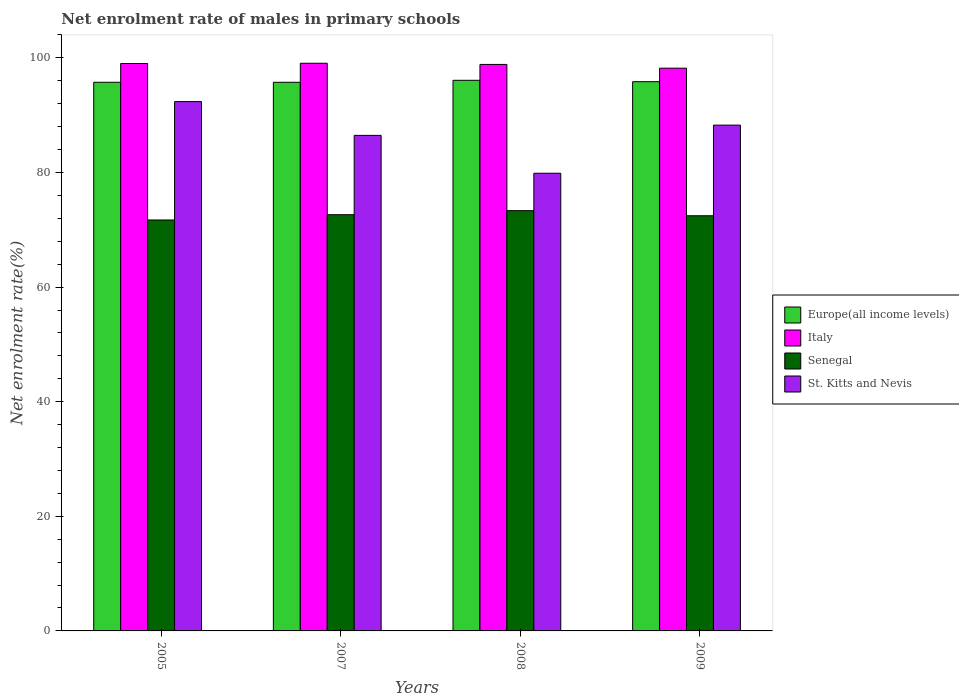How many groups of bars are there?
Your answer should be very brief. 4. Are the number of bars on each tick of the X-axis equal?
Your response must be concise. Yes. What is the net enrolment rate of males in primary schools in Senegal in 2005?
Give a very brief answer. 71.71. Across all years, what is the maximum net enrolment rate of males in primary schools in Senegal?
Your response must be concise. 73.33. Across all years, what is the minimum net enrolment rate of males in primary schools in Europe(all income levels)?
Provide a succinct answer. 95.74. What is the total net enrolment rate of males in primary schools in St. Kitts and Nevis in the graph?
Offer a very short reply. 346.96. What is the difference between the net enrolment rate of males in primary schools in Europe(all income levels) in 2008 and that in 2009?
Your response must be concise. 0.24. What is the difference between the net enrolment rate of males in primary schools in Senegal in 2008 and the net enrolment rate of males in primary schools in Europe(all income levels) in 2007?
Your answer should be very brief. -22.4. What is the average net enrolment rate of males in primary schools in St. Kitts and Nevis per year?
Offer a very short reply. 86.74. In the year 2009, what is the difference between the net enrolment rate of males in primary schools in Italy and net enrolment rate of males in primary schools in Senegal?
Offer a terse response. 25.75. What is the ratio of the net enrolment rate of males in primary schools in St. Kitts and Nevis in 2007 to that in 2009?
Provide a succinct answer. 0.98. Is the net enrolment rate of males in primary schools in Italy in 2008 less than that in 2009?
Your answer should be compact. No. What is the difference between the highest and the second highest net enrolment rate of males in primary schools in Europe(all income levels)?
Give a very brief answer. 0.24. What is the difference between the highest and the lowest net enrolment rate of males in primary schools in Italy?
Offer a terse response. 0.86. In how many years, is the net enrolment rate of males in primary schools in Senegal greater than the average net enrolment rate of males in primary schools in Senegal taken over all years?
Offer a terse response. 2. Is it the case that in every year, the sum of the net enrolment rate of males in primary schools in Europe(all income levels) and net enrolment rate of males in primary schools in Italy is greater than the sum of net enrolment rate of males in primary schools in Senegal and net enrolment rate of males in primary schools in St. Kitts and Nevis?
Your answer should be very brief. Yes. What does the 3rd bar from the left in 2008 represents?
Keep it short and to the point. Senegal. What does the 1st bar from the right in 2005 represents?
Your answer should be compact. St. Kitts and Nevis. How many bars are there?
Your answer should be very brief. 16. Are all the bars in the graph horizontal?
Offer a terse response. No. What is the difference between two consecutive major ticks on the Y-axis?
Provide a succinct answer. 20. Are the values on the major ticks of Y-axis written in scientific E-notation?
Ensure brevity in your answer.  No. Where does the legend appear in the graph?
Provide a succinct answer. Center right. How are the legend labels stacked?
Offer a very short reply. Vertical. What is the title of the graph?
Provide a short and direct response. Net enrolment rate of males in primary schools. Does "El Salvador" appear as one of the legend labels in the graph?
Make the answer very short. No. What is the label or title of the X-axis?
Give a very brief answer. Years. What is the label or title of the Y-axis?
Ensure brevity in your answer.  Net enrolment rate(%). What is the Net enrolment rate(%) of Europe(all income levels) in 2005?
Keep it short and to the point. 95.74. What is the Net enrolment rate(%) of Italy in 2005?
Your answer should be compact. 99.01. What is the Net enrolment rate(%) of Senegal in 2005?
Make the answer very short. 71.71. What is the Net enrolment rate(%) in St. Kitts and Nevis in 2005?
Keep it short and to the point. 92.36. What is the Net enrolment rate(%) of Europe(all income levels) in 2007?
Make the answer very short. 95.74. What is the Net enrolment rate(%) in Italy in 2007?
Keep it short and to the point. 99.06. What is the Net enrolment rate(%) in Senegal in 2007?
Your response must be concise. 72.63. What is the Net enrolment rate(%) of St. Kitts and Nevis in 2007?
Your answer should be compact. 86.47. What is the Net enrolment rate(%) in Europe(all income levels) in 2008?
Make the answer very short. 96.08. What is the Net enrolment rate(%) of Italy in 2008?
Offer a terse response. 98.85. What is the Net enrolment rate(%) in Senegal in 2008?
Offer a terse response. 73.33. What is the Net enrolment rate(%) in St. Kitts and Nevis in 2008?
Give a very brief answer. 79.86. What is the Net enrolment rate(%) of Europe(all income levels) in 2009?
Give a very brief answer. 95.84. What is the Net enrolment rate(%) of Italy in 2009?
Offer a terse response. 98.2. What is the Net enrolment rate(%) of Senegal in 2009?
Your answer should be very brief. 72.45. What is the Net enrolment rate(%) in St. Kitts and Nevis in 2009?
Your response must be concise. 88.26. Across all years, what is the maximum Net enrolment rate(%) in Europe(all income levels)?
Your answer should be very brief. 96.08. Across all years, what is the maximum Net enrolment rate(%) of Italy?
Your answer should be very brief. 99.06. Across all years, what is the maximum Net enrolment rate(%) in Senegal?
Your response must be concise. 73.33. Across all years, what is the maximum Net enrolment rate(%) of St. Kitts and Nevis?
Provide a succinct answer. 92.36. Across all years, what is the minimum Net enrolment rate(%) in Europe(all income levels)?
Make the answer very short. 95.74. Across all years, what is the minimum Net enrolment rate(%) of Italy?
Provide a short and direct response. 98.2. Across all years, what is the minimum Net enrolment rate(%) of Senegal?
Your response must be concise. 71.71. Across all years, what is the minimum Net enrolment rate(%) in St. Kitts and Nevis?
Your response must be concise. 79.86. What is the total Net enrolment rate(%) in Europe(all income levels) in the graph?
Ensure brevity in your answer.  383.39. What is the total Net enrolment rate(%) in Italy in the graph?
Provide a succinct answer. 395.12. What is the total Net enrolment rate(%) in Senegal in the graph?
Your answer should be very brief. 290.12. What is the total Net enrolment rate(%) of St. Kitts and Nevis in the graph?
Keep it short and to the point. 346.96. What is the difference between the Net enrolment rate(%) of Europe(all income levels) in 2005 and that in 2007?
Provide a short and direct response. 0. What is the difference between the Net enrolment rate(%) in Italy in 2005 and that in 2007?
Your response must be concise. -0.04. What is the difference between the Net enrolment rate(%) in Senegal in 2005 and that in 2007?
Your response must be concise. -0.92. What is the difference between the Net enrolment rate(%) of St. Kitts and Nevis in 2005 and that in 2007?
Offer a terse response. 5.89. What is the difference between the Net enrolment rate(%) of Europe(all income levels) in 2005 and that in 2008?
Offer a very short reply. -0.34. What is the difference between the Net enrolment rate(%) of Italy in 2005 and that in 2008?
Give a very brief answer. 0.16. What is the difference between the Net enrolment rate(%) of Senegal in 2005 and that in 2008?
Provide a short and direct response. -1.63. What is the difference between the Net enrolment rate(%) of St. Kitts and Nevis in 2005 and that in 2008?
Provide a short and direct response. 12.5. What is the difference between the Net enrolment rate(%) in Europe(all income levels) in 2005 and that in 2009?
Provide a succinct answer. -0.1. What is the difference between the Net enrolment rate(%) of Italy in 2005 and that in 2009?
Provide a succinct answer. 0.81. What is the difference between the Net enrolment rate(%) in Senegal in 2005 and that in 2009?
Provide a succinct answer. -0.74. What is the difference between the Net enrolment rate(%) in St. Kitts and Nevis in 2005 and that in 2009?
Provide a short and direct response. 4.1. What is the difference between the Net enrolment rate(%) of Europe(all income levels) in 2007 and that in 2008?
Ensure brevity in your answer.  -0.34. What is the difference between the Net enrolment rate(%) in Italy in 2007 and that in 2008?
Your answer should be very brief. 0.2. What is the difference between the Net enrolment rate(%) in Senegal in 2007 and that in 2008?
Offer a very short reply. -0.71. What is the difference between the Net enrolment rate(%) in St. Kitts and Nevis in 2007 and that in 2008?
Make the answer very short. 6.61. What is the difference between the Net enrolment rate(%) in Europe(all income levels) in 2007 and that in 2009?
Your response must be concise. -0.1. What is the difference between the Net enrolment rate(%) of Italy in 2007 and that in 2009?
Give a very brief answer. 0.86. What is the difference between the Net enrolment rate(%) in Senegal in 2007 and that in 2009?
Offer a very short reply. 0.18. What is the difference between the Net enrolment rate(%) of St. Kitts and Nevis in 2007 and that in 2009?
Give a very brief answer. -1.79. What is the difference between the Net enrolment rate(%) of Europe(all income levels) in 2008 and that in 2009?
Provide a short and direct response. 0.24. What is the difference between the Net enrolment rate(%) in Italy in 2008 and that in 2009?
Offer a very short reply. 0.65. What is the difference between the Net enrolment rate(%) of Senegal in 2008 and that in 2009?
Make the answer very short. 0.89. What is the difference between the Net enrolment rate(%) in St. Kitts and Nevis in 2008 and that in 2009?
Offer a terse response. -8.4. What is the difference between the Net enrolment rate(%) of Europe(all income levels) in 2005 and the Net enrolment rate(%) of Italy in 2007?
Provide a succinct answer. -3.32. What is the difference between the Net enrolment rate(%) of Europe(all income levels) in 2005 and the Net enrolment rate(%) of Senegal in 2007?
Ensure brevity in your answer.  23.11. What is the difference between the Net enrolment rate(%) in Europe(all income levels) in 2005 and the Net enrolment rate(%) in St. Kitts and Nevis in 2007?
Offer a terse response. 9.27. What is the difference between the Net enrolment rate(%) in Italy in 2005 and the Net enrolment rate(%) in Senegal in 2007?
Your response must be concise. 26.38. What is the difference between the Net enrolment rate(%) in Italy in 2005 and the Net enrolment rate(%) in St. Kitts and Nevis in 2007?
Give a very brief answer. 12.54. What is the difference between the Net enrolment rate(%) of Senegal in 2005 and the Net enrolment rate(%) of St. Kitts and Nevis in 2007?
Provide a succinct answer. -14.76. What is the difference between the Net enrolment rate(%) of Europe(all income levels) in 2005 and the Net enrolment rate(%) of Italy in 2008?
Offer a very short reply. -3.11. What is the difference between the Net enrolment rate(%) of Europe(all income levels) in 2005 and the Net enrolment rate(%) of Senegal in 2008?
Your answer should be compact. 22.4. What is the difference between the Net enrolment rate(%) in Europe(all income levels) in 2005 and the Net enrolment rate(%) in St. Kitts and Nevis in 2008?
Offer a very short reply. 15.87. What is the difference between the Net enrolment rate(%) in Italy in 2005 and the Net enrolment rate(%) in Senegal in 2008?
Your response must be concise. 25.68. What is the difference between the Net enrolment rate(%) in Italy in 2005 and the Net enrolment rate(%) in St. Kitts and Nevis in 2008?
Keep it short and to the point. 19.15. What is the difference between the Net enrolment rate(%) in Senegal in 2005 and the Net enrolment rate(%) in St. Kitts and Nevis in 2008?
Provide a short and direct response. -8.15. What is the difference between the Net enrolment rate(%) in Europe(all income levels) in 2005 and the Net enrolment rate(%) in Italy in 2009?
Keep it short and to the point. -2.46. What is the difference between the Net enrolment rate(%) of Europe(all income levels) in 2005 and the Net enrolment rate(%) of Senegal in 2009?
Give a very brief answer. 23.29. What is the difference between the Net enrolment rate(%) in Europe(all income levels) in 2005 and the Net enrolment rate(%) in St. Kitts and Nevis in 2009?
Offer a terse response. 7.48. What is the difference between the Net enrolment rate(%) of Italy in 2005 and the Net enrolment rate(%) of Senegal in 2009?
Provide a succinct answer. 26.57. What is the difference between the Net enrolment rate(%) of Italy in 2005 and the Net enrolment rate(%) of St. Kitts and Nevis in 2009?
Offer a terse response. 10.75. What is the difference between the Net enrolment rate(%) of Senegal in 2005 and the Net enrolment rate(%) of St. Kitts and Nevis in 2009?
Offer a terse response. -16.55. What is the difference between the Net enrolment rate(%) of Europe(all income levels) in 2007 and the Net enrolment rate(%) of Italy in 2008?
Keep it short and to the point. -3.12. What is the difference between the Net enrolment rate(%) of Europe(all income levels) in 2007 and the Net enrolment rate(%) of Senegal in 2008?
Your answer should be very brief. 22.4. What is the difference between the Net enrolment rate(%) of Europe(all income levels) in 2007 and the Net enrolment rate(%) of St. Kitts and Nevis in 2008?
Provide a short and direct response. 15.87. What is the difference between the Net enrolment rate(%) of Italy in 2007 and the Net enrolment rate(%) of Senegal in 2008?
Give a very brief answer. 25.72. What is the difference between the Net enrolment rate(%) in Italy in 2007 and the Net enrolment rate(%) in St. Kitts and Nevis in 2008?
Provide a short and direct response. 19.19. What is the difference between the Net enrolment rate(%) of Senegal in 2007 and the Net enrolment rate(%) of St. Kitts and Nevis in 2008?
Offer a very short reply. -7.24. What is the difference between the Net enrolment rate(%) of Europe(all income levels) in 2007 and the Net enrolment rate(%) of Italy in 2009?
Provide a succinct answer. -2.46. What is the difference between the Net enrolment rate(%) in Europe(all income levels) in 2007 and the Net enrolment rate(%) in Senegal in 2009?
Give a very brief answer. 23.29. What is the difference between the Net enrolment rate(%) in Europe(all income levels) in 2007 and the Net enrolment rate(%) in St. Kitts and Nevis in 2009?
Your answer should be very brief. 7.47. What is the difference between the Net enrolment rate(%) in Italy in 2007 and the Net enrolment rate(%) in Senegal in 2009?
Your response must be concise. 26.61. What is the difference between the Net enrolment rate(%) of Italy in 2007 and the Net enrolment rate(%) of St. Kitts and Nevis in 2009?
Make the answer very short. 10.8. What is the difference between the Net enrolment rate(%) of Senegal in 2007 and the Net enrolment rate(%) of St. Kitts and Nevis in 2009?
Offer a very short reply. -15.63. What is the difference between the Net enrolment rate(%) of Europe(all income levels) in 2008 and the Net enrolment rate(%) of Italy in 2009?
Your response must be concise. -2.12. What is the difference between the Net enrolment rate(%) in Europe(all income levels) in 2008 and the Net enrolment rate(%) in Senegal in 2009?
Give a very brief answer. 23.64. What is the difference between the Net enrolment rate(%) of Europe(all income levels) in 2008 and the Net enrolment rate(%) of St. Kitts and Nevis in 2009?
Give a very brief answer. 7.82. What is the difference between the Net enrolment rate(%) in Italy in 2008 and the Net enrolment rate(%) in Senegal in 2009?
Ensure brevity in your answer.  26.41. What is the difference between the Net enrolment rate(%) in Italy in 2008 and the Net enrolment rate(%) in St. Kitts and Nevis in 2009?
Provide a succinct answer. 10.59. What is the difference between the Net enrolment rate(%) of Senegal in 2008 and the Net enrolment rate(%) of St. Kitts and Nevis in 2009?
Give a very brief answer. -14.93. What is the average Net enrolment rate(%) of Europe(all income levels) per year?
Offer a terse response. 95.85. What is the average Net enrolment rate(%) in Italy per year?
Your answer should be very brief. 98.78. What is the average Net enrolment rate(%) of Senegal per year?
Your response must be concise. 72.53. What is the average Net enrolment rate(%) of St. Kitts and Nevis per year?
Offer a very short reply. 86.74. In the year 2005, what is the difference between the Net enrolment rate(%) in Europe(all income levels) and Net enrolment rate(%) in Italy?
Ensure brevity in your answer.  -3.27. In the year 2005, what is the difference between the Net enrolment rate(%) of Europe(all income levels) and Net enrolment rate(%) of Senegal?
Your answer should be compact. 24.03. In the year 2005, what is the difference between the Net enrolment rate(%) of Europe(all income levels) and Net enrolment rate(%) of St. Kitts and Nevis?
Offer a terse response. 3.37. In the year 2005, what is the difference between the Net enrolment rate(%) in Italy and Net enrolment rate(%) in Senegal?
Provide a short and direct response. 27.3. In the year 2005, what is the difference between the Net enrolment rate(%) of Italy and Net enrolment rate(%) of St. Kitts and Nevis?
Offer a very short reply. 6.65. In the year 2005, what is the difference between the Net enrolment rate(%) in Senegal and Net enrolment rate(%) in St. Kitts and Nevis?
Make the answer very short. -20.66. In the year 2007, what is the difference between the Net enrolment rate(%) of Europe(all income levels) and Net enrolment rate(%) of Italy?
Your answer should be very brief. -3.32. In the year 2007, what is the difference between the Net enrolment rate(%) of Europe(all income levels) and Net enrolment rate(%) of Senegal?
Make the answer very short. 23.11. In the year 2007, what is the difference between the Net enrolment rate(%) in Europe(all income levels) and Net enrolment rate(%) in St. Kitts and Nevis?
Make the answer very short. 9.27. In the year 2007, what is the difference between the Net enrolment rate(%) in Italy and Net enrolment rate(%) in Senegal?
Keep it short and to the point. 26.43. In the year 2007, what is the difference between the Net enrolment rate(%) in Italy and Net enrolment rate(%) in St. Kitts and Nevis?
Provide a succinct answer. 12.59. In the year 2007, what is the difference between the Net enrolment rate(%) in Senegal and Net enrolment rate(%) in St. Kitts and Nevis?
Keep it short and to the point. -13.84. In the year 2008, what is the difference between the Net enrolment rate(%) of Europe(all income levels) and Net enrolment rate(%) of Italy?
Keep it short and to the point. -2.77. In the year 2008, what is the difference between the Net enrolment rate(%) in Europe(all income levels) and Net enrolment rate(%) in Senegal?
Your response must be concise. 22.75. In the year 2008, what is the difference between the Net enrolment rate(%) in Europe(all income levels) and Net enrolment rate(%) in St. Kitts and Nevis?
Make the answer very short. 16.22. In the year 2008, what is the difference between the Net enrolment rate(%) of Italy and Net enrolment rate(%) of Senegal?
Your answer should be very brief. 25.52. In the year 2008, what is the difference between the Net enrolment rate(%) in Italy and Net enrolment rate(%) in St. Kitts and Nevis?
Provide a succinct answer. 18.99. In the year 2008, what is the difference between the Net enrolment rate(%) in Senegal and Net enrolment rate(%) in St. Kitts and Nevis?
Give a very brief answer. -6.53. In the year 2009, what is the difference between the Net enrolment rate(%) of Europe(all income levels) and Net enrolment rate(%) of Italy?
Give a very brief answer. -2.36. In the year 2009, what is the difference between the Net enrolment rate(%) of Europe(all income levels) and Net enrolment rate(%) of Senegal?
Make the answer very short. 23.39. In the year 2009, what is the difference between the Net enrolment rate(%) in Europe(all income levels) and Net enrolment rate(%) in St. Kitts and Nevis?
Give a very brief answer. 7.58. In the year 2009, what is the difference between the Net enrolment rate(%) of Italy and Net enrolment rate(%) of Senegal?
Provide a short and direct response. 25.75. In the year 2009, what is the difference between the Net enrolment rate(%) in Italy and Net enrolment rate(%) in St. Kitts and Nevis?
Your answer should be very brief. 9.94. In the year 2009, what is the difference between the Net enrolment rate(%) in Senegal and Net enrolment rate(%) in St. Kitts and Nevis?
Offer a terse response. -15.82. What is the ratio of the Net enrolment rate(%) of Europe(all income levels) in 2005 to that in 2007?
Keep it short and to the point. 1. What is the ratio of the Net enrolment rate(%) in Senegal in 2005 to that in 2007?
Provide a succinct answer. 0.99. What is the ratio of the Net enrolment rate(%) of St. Kitts and Nevis in 2005 to that in 2007?
Give a very brief answer. 1.07. What is the ratio of the Net enrolment rate(%) of Europe(all income levels) in 2005 to that in 2008?
Your response must be concise. 1. What is the ratio of the Net enrolment rate(%) in Senegal in 2005 to that in 2008?
Ensure brevity in your answer.  0.98. What is the ratio of the Net enrolment rate(%) in St. Kitts and Nevis in 2005 to that in 2008?
Make the answer very short. 1.16. What is the ratio of the Net enrolment rate(%) in Europe(all income levels) in 2005 to that in 2009?
Your response must be concise. 1. What is the ratio of the Net enrolment rate(%) of Italy in 2005 to that in 2009?
Make the answer very short. 1.01. What is the ratio of the Net enrolment rate(%) in Senegal in 2005 to that in 2009?
Provide a succinct answer. 0.99. What is the ratio of the Net enrolment rate(%) of St. Kitts and Nevis in 2005 to that in 2009?
Offer a terse response. 1.05. What is the ratio of the Net enrolment rate(%) in Italy in 2007 to that in 2008?
Make the answer very short. 1. What is the ratio of the Net enrolment rate(%) in St. Kitts and Nevis in 2007 to that in 2008?
Provide a short and direct response. 1.08. What is the ratio of the Net enrolment rate(%) in Italy in 2007 to that in 2009?
Give a very brief answer. 1.01. What is the ratio of the Net enrolment rate(%) of St. Kitts and Nevis in 2007 to that in 2009?
Keep it short and to the point. 0.98. What is the ratio of the Net enrolment rate(%) in Europe(all income levels) in 2008 to that in 2009?
Provide a succinct answer. 1. What is the ratio of the Net enrolment rate(%) in Italy in 2008 to that in 2009?
Your answer should be compact. 1.01. What is the ratio of the Net enrolment rate(%) in Senegal in 2008 to that in 2009?
Offer a terse response. 1.01. What is the ratio of the Net enrolment rate(%) of St. Kitts and Nevis in 2008 to that in 2009?
Provide a short and direct response. 0.9. What is the difference between the highest and the second highest Net enrolment rate(%) of Europe(all income levels)?
Make the answer very short. 0.24. What is the difference between the highest and the second highest Net enrolment rate(%) in Italy?
Offer a very short reply. 0.04. What is the difference between the highest and the second highest Net enrolment rate(%) of Senegal?
Make the answer very short. 0.71. What is the difference between the highest and the second highest Net enrolment rate(%) of St. Kitts and Nevis?
Offer a very short reply. 4.1. What is the difference between the highest and the lowest Net enrolment rate(%) of Europe(all income levels)?
Give a very brief answer. 0.34. What is the difference between the highest and the lowest Net enrolment rate(%) of Italy?
Provide a short and direct response. 0.86. What is the difference between the highest and the lowest Net enrolment rate(%) of Senegal?
Keep it short and to the point. 1.63. What is the difference between the highest and the lowest Net enrolment rate(%) of St. Kitts and Nevis?
Provide a short and direct response. 12.5. 